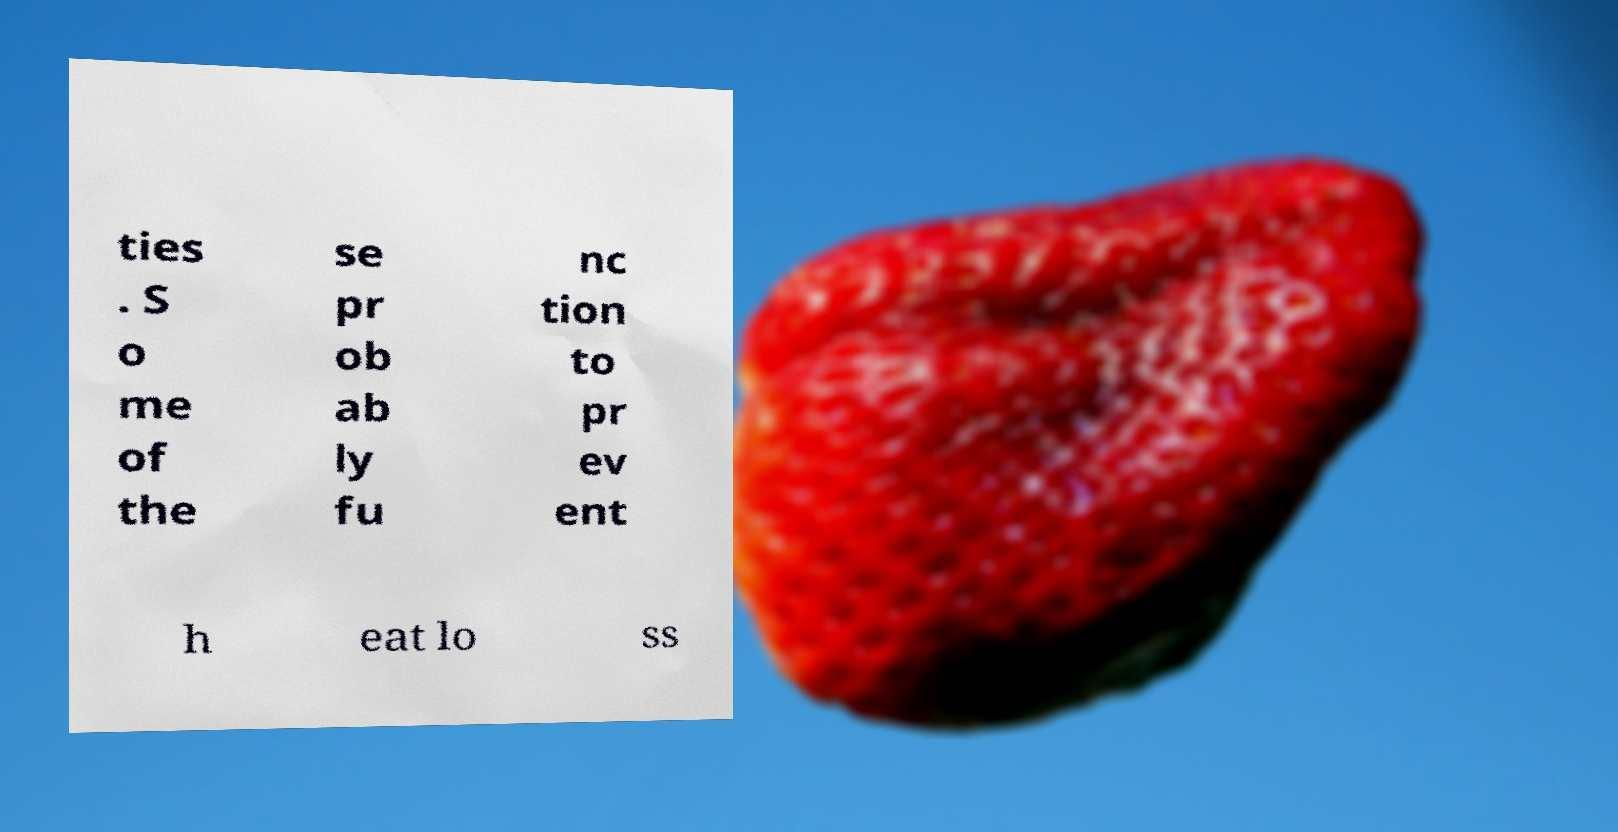Please read and relay the text visible in this image. What does it say? ties . S o me of the se pr ob ab ly fu nc tion to pr ev ent h eat lo ss 